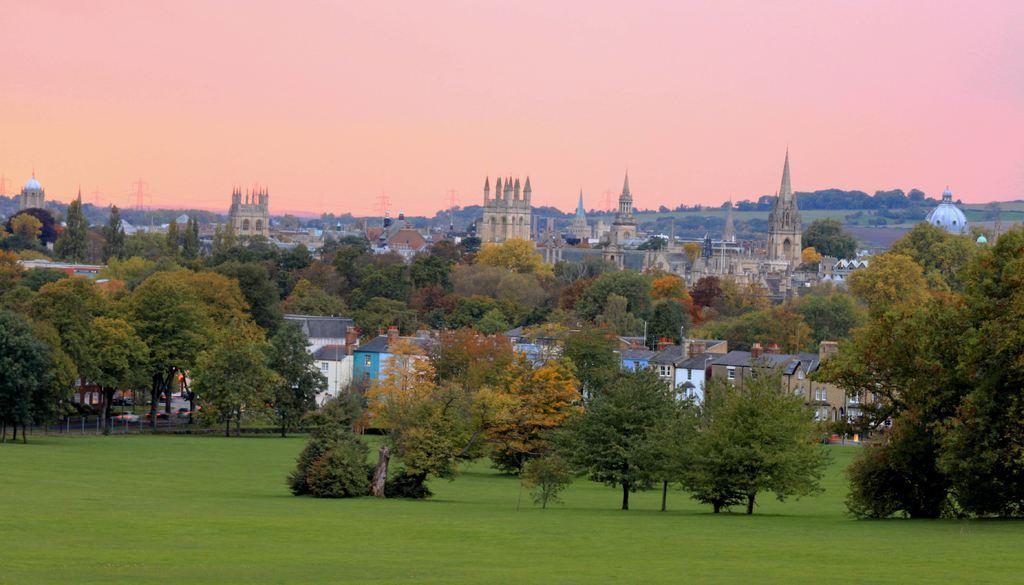Describe this image in one or two sentences. In this picture we can see trees, buildings with windows, grass, fence and in the background we can see the sky. 